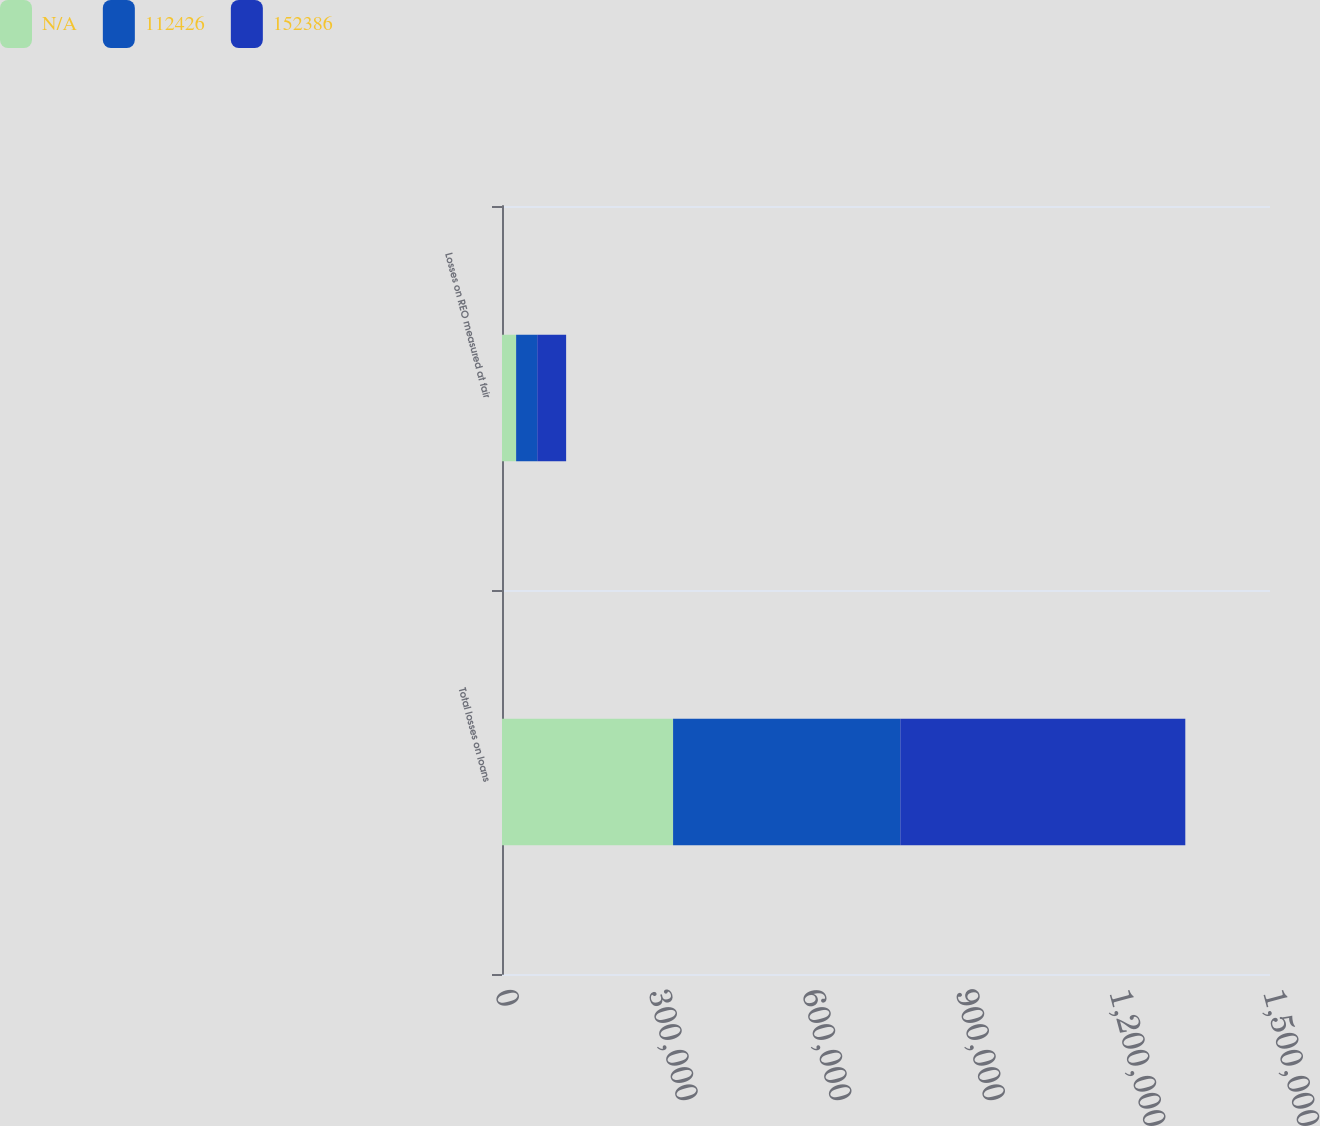Convert chart to OTSL. <chart><loc_0><loc_0><loc_500><loc_500><stacked_bar_chart><ecel><fcel>Total losses on loans<fcel>Losses on REO measured at fair<nl><fcel>nan<fcel>334143<fcel>27582<nl><fcel>112426<fcel>443737<fcel>41203<nl><fcel>152386<fcel>556685<fcel>56460<nl></chart> 